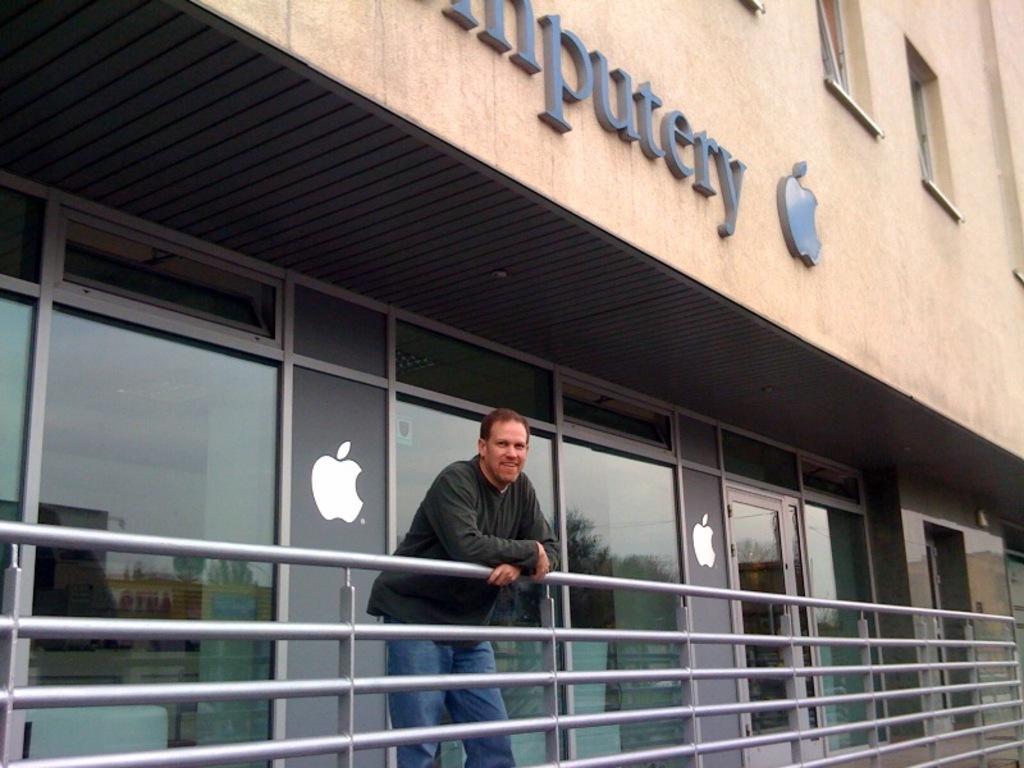Describe this image in one or two sentences. In this picture we can see a man standing, railing, building, glass objects with the reflection of trees, buildings and the sky on it and some objects. 